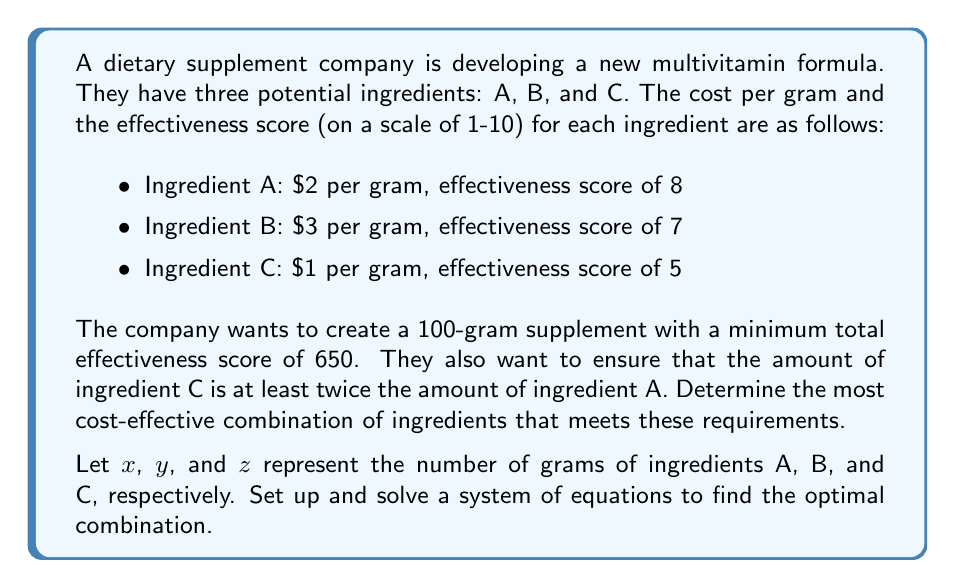Give your solution to this math problem. To solve this problem, we need to set up a system of equations based on the given constraints and then minimize the cost function. Let's approach this step-by-step:

1. First, let's define our variables:
   $x$ = grams of ingredient A
   $y$ = grams of ingredient B
   $z$ = grams of ingredient C

2. Now, let's set up our constraints:

   a) Total weight constraint:
      $$x + y + z = 100$$

   b) Minimum effectiveness score constraint:
      $$8x + 7y + 5z \geq 650$$

   c) Ingredient C being at least twice ingredient A:
      $$z \geq 2x$$

3. Our objective is to minimize the cost function:
   $$\text{Cost} = 2x + 3y + z$$

4. We can solve this using linear programming. However, for a simpler approach, we can use the constraint $z \geq 2x$ to eliminate one variable. Let's set $z = 2x + w$, where $w \geq 0$.

5. Substituting this into our equations:

   a) $x + y + (2x + w) = 100$
      $3x + y + w = 100$

   b) $8x + 7y + 5(2x + w) \geq 650$
      $18x + 7y + 5w \geq 650$

6. Now we have a system of two equations with three variables. We can use the first equation to express $y$ in terms of $x$ and $w$:

   $y = 100 - 3x - w$

7. Substituting this into the second equation:

   $18x + 7(100 - 3x - w) + 5w \geq 650$
   $18x + 700 - 21x - 7w + 5w \geq 650$
   $-3x - 2w \geq -50$

8. Our cost function becomes:

   $\text{Cost} = 2x + 3(100 - 3x - w) + (2x + w)$
   $= 2x + 300 - 9x - 3w + 2x + w$
   $= 300 - 5x - 2w$

9. To minimize cost, we want to maximize $5x + 2w$ subject to the constraints:

   $3x + w \leq 100$
   $3x + 2w \geq 50$
   $x, w \geq 0$

10. The optimal solution occurs at the intersection of these constraints:

    $3x + 2w = 50$
    $3x + w = 100$

    Solving these simultaneously:
    $w = 50$
    $x = 50/3 \approx 16.67$

11. Therefore:
    $x \approx 16.67$
    $y = 100 - 3x - w = 100 - 3(16.67) - 50 \approx 0$
    $z = 2x + w = 2(16.67) + 50 \approx 83.33$
Answer: The most cost-effective combination is approximately:
Ingredient A: 16.67 grams
Ingredient B: 0 grams
Ingredient C: 83.33 grams

Total cost: $2(16.67) + $3(0) + $1(83.33) = $116.67 